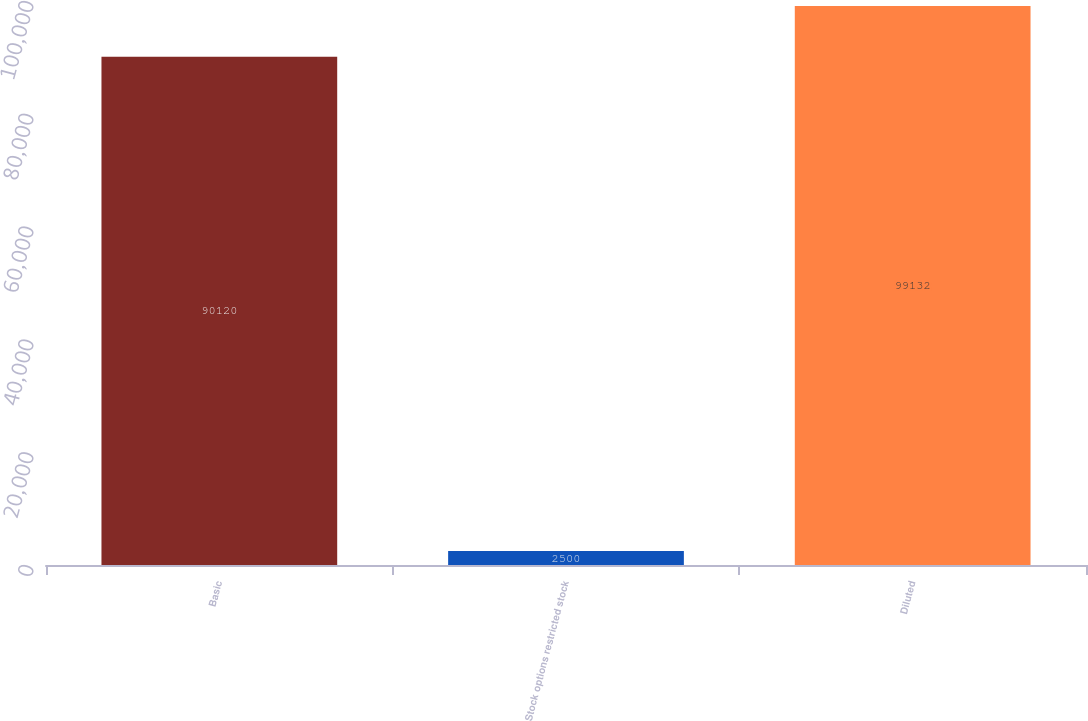Convert chart to OTSL. <chart><loc_0><loc_0><loc_500><loc_500><bar_chart><fcel>Basic<fcel>Stock options restricted stock<fcel>Diluted<nl><fcel>90120<fcel>2500<fcel>99132<nl></chart> 